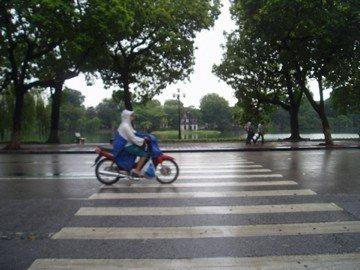Question: where was the picture taken?
Choices:
A. In the bedroom.
B. In his house.
C. In a city.
D. At the pool.
Answer with the letter. Answer: C Question: what kind of vehicle is there?
Choices:
A. A scooter.
B. A car.
C. A bus.
D. A plane.
Answer with the letter. Answer: A Question: what kind of weather was happening?
Choices:
A. Snowstorm.
B. Rain.
C. Thunderstorm.
D. Tornado.
Answer with the letter. Answer: B Question: what is the road made of?
Choices:
A. Pebbles.
B. Asphalt.
C. Dirt.
D. Concrete.
Answer with the letter. Answer: B 